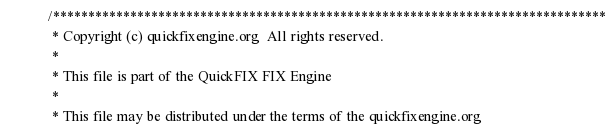<code> <loc_0><loc_0><loc_500><loc_500><_Java_>/*******************************************************************************
 * Copyright (c) quickfixengine.org  All rights reserved. 
 * 
 * This file is part of the QuickFIX FIX Engine 
 * 
 * This file may be distributed under the terms of the quickfixengine.org </code> 